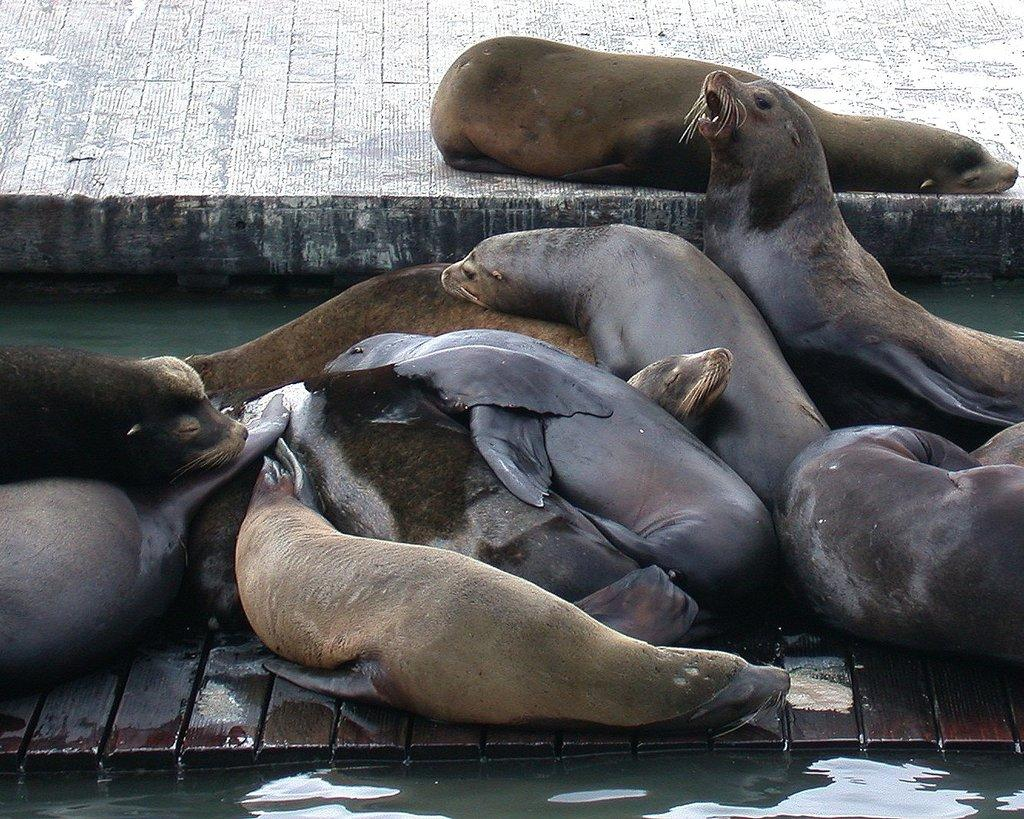What animals are present in the image? There are sea lions in the image. Where are the sea lions located in relation to the water? The sea lions are beside the water. What type of vase can be seen in the image? There is no vase present in the image; it features sea lions beside the water. How many tails does the sea lion have in the image? It is difficult to determine the exact number of tails from the image, but sea lions typically have two tails. 